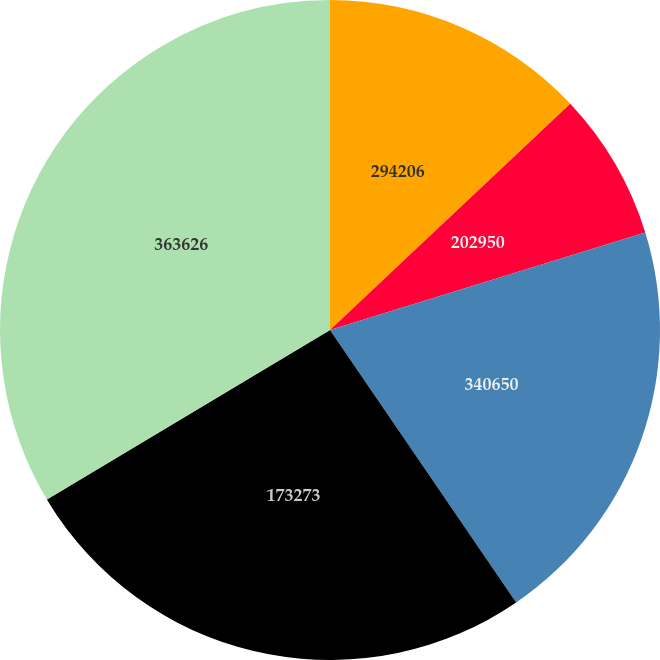Convert chart. <chart><loc_0><loc_0><loc_500><loc_500><pie_chart><fcel>294206<fcel>202950<fcel>340650<fcel>173273<fcel>363626<nl><fcel>12.98%<fcel>7.25%<fcel>20.23%<fcel>25.95%<fcel>33.59%<nl></chart> 